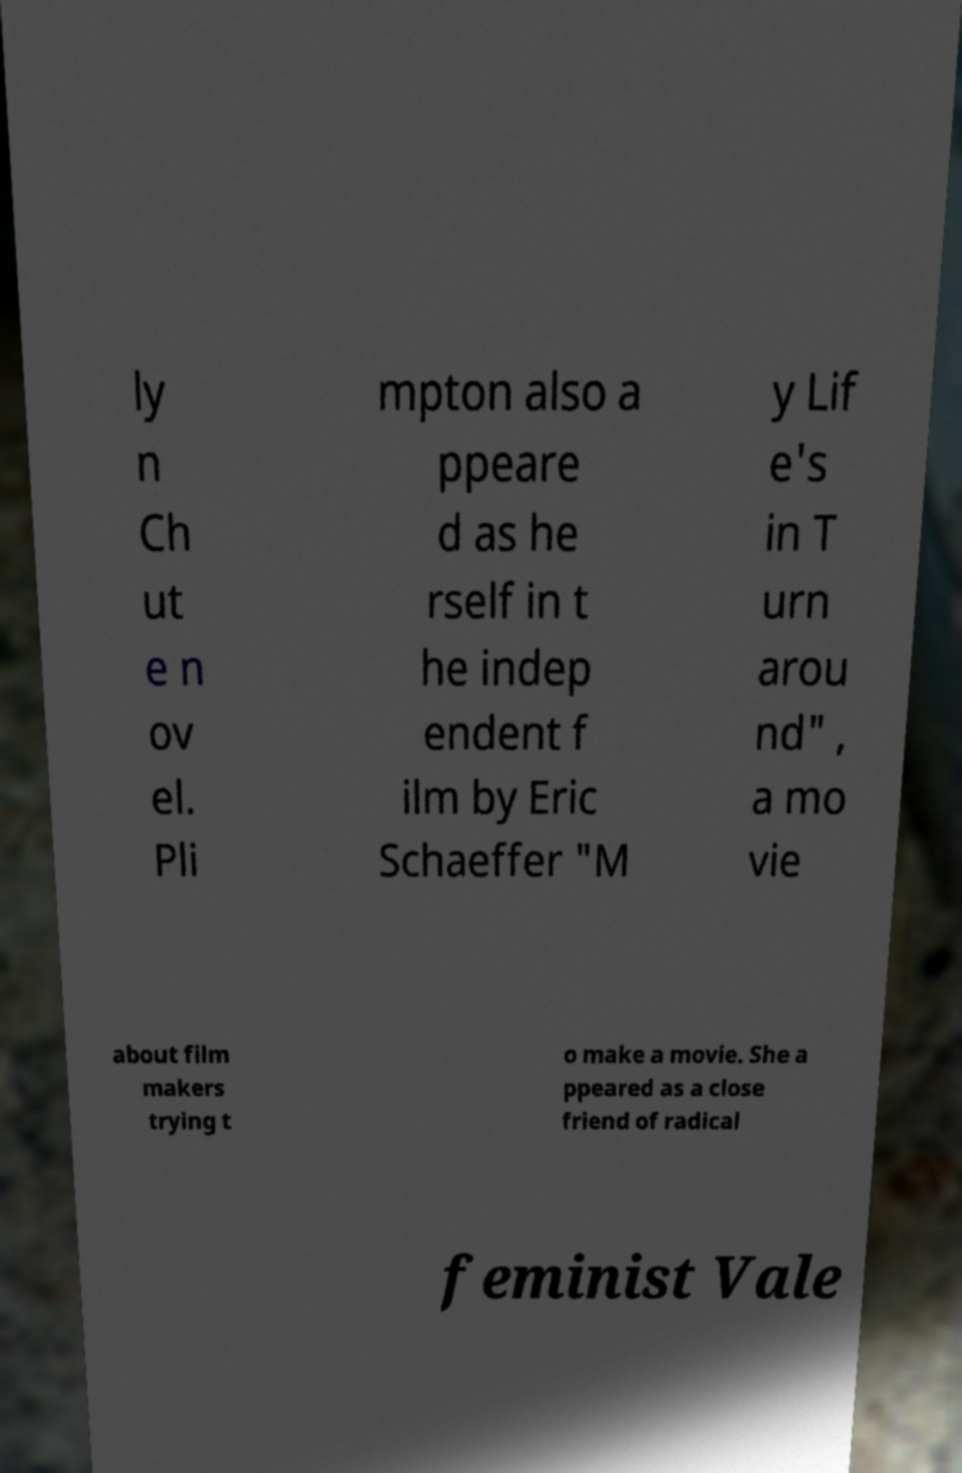What messages or text are displayed in this image? I need them in a readable, typed format. ly n Ch ut e n ov el. Pli mpton also a ppeare d as he rself in t he indep endent f ilm by Eric Schaeffer "M y Lif e's in T urn arou nd" , a mo vie about film makers trying t o make a movie. She a ppeared as a close friend of radical feminist Vale 